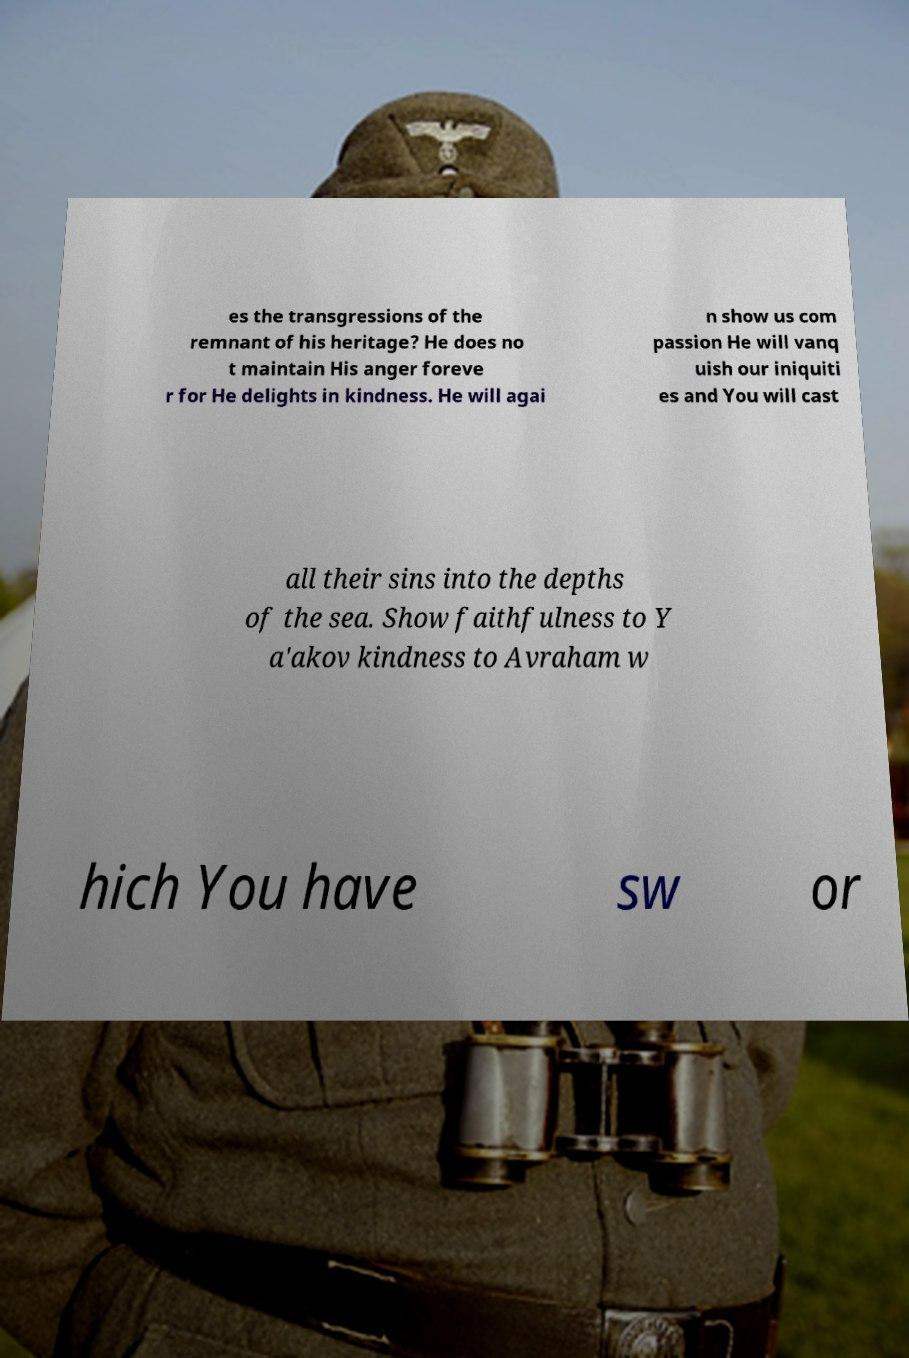Please identify and transcribe the text found in this image. es the transgressions of the remnant of his heritage? He does no t maintain His anger foreve r for He delights in kindness. He will agai n show us com passion He will vanq uish our iniquiti es and You will cast all their sins into the depths of the sea. Show faithfulness to Y a'akov kindness to Avraham w hich You have sw or 